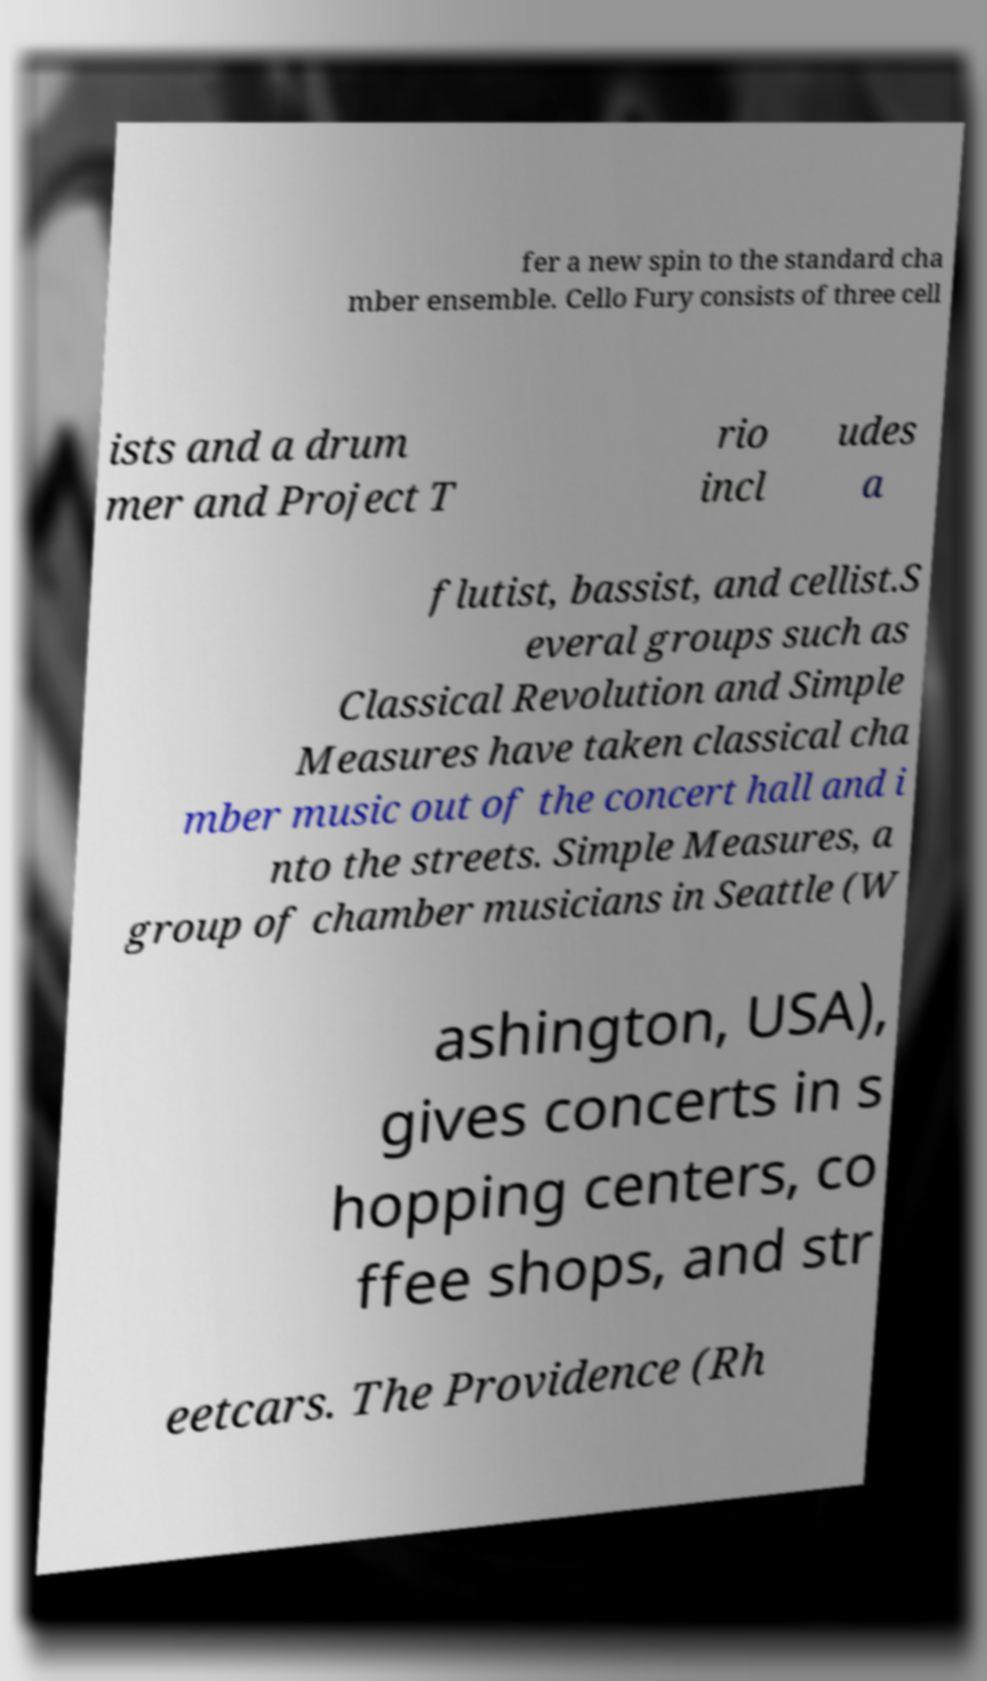Please identify and transcribe the text found in this image. fer a new spin to the standard cha mber ensemble. Cello Fury consists of three cell ists and a drum mer and Project T rio incl udes a flutist, bassist, and cellist.S everal groups such as Classical Revolution and Simple Measures have taken classical cha mber music out of the concert hall and i nto the streets. Simple Measures, a group of chamber musicians in Seattle (W ashington, USA), gives concerts in s hopping centers, co ffee shops, and str eetcars. The Providence (Rh 